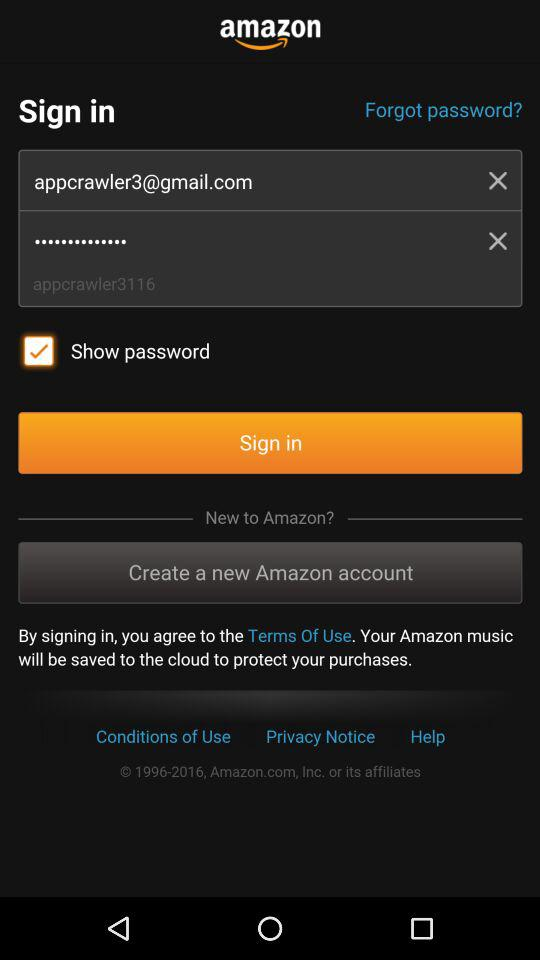What is the status of the "Show password"? The status of the "Show password" is "on". 